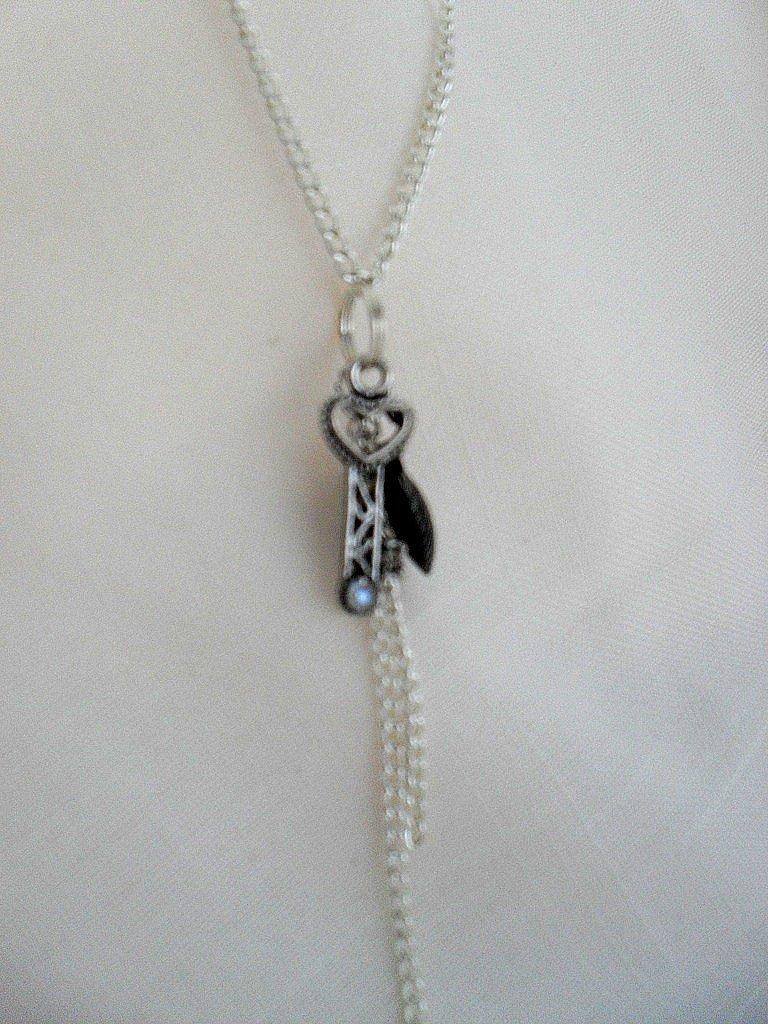What is the main object in the image? There is a chain in the image. What is the chain placed on? The chain is on a cloth. What knowledge does the chain possess in the image? The chain does not possess knowledge, as it is an inanimate object. 